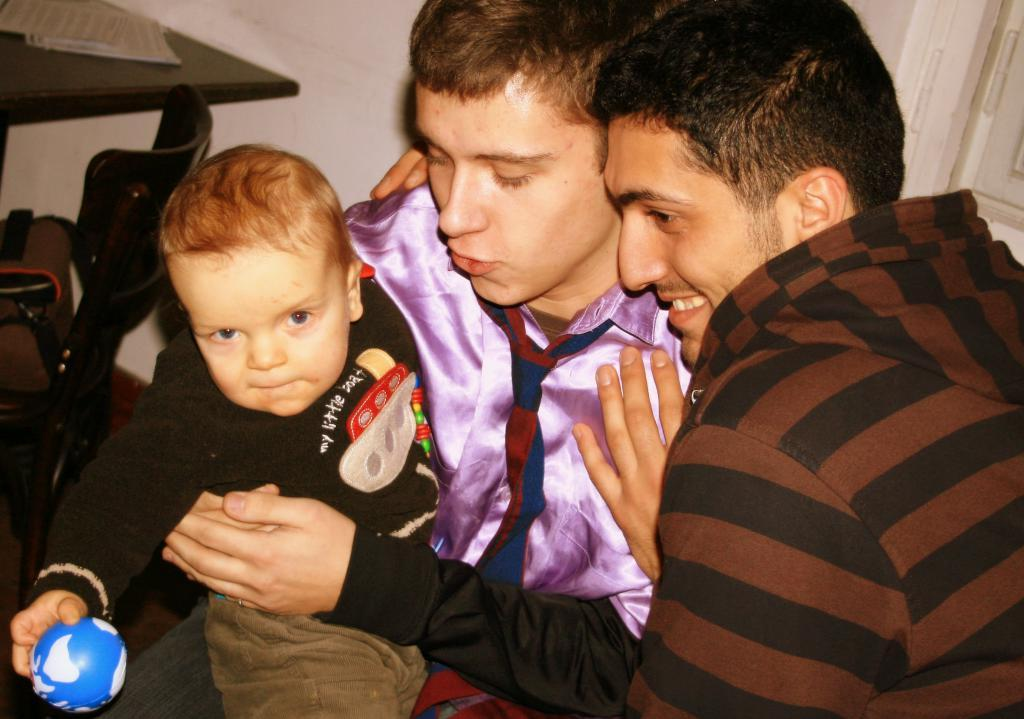How many people are in the image? There are three people in the image: two men and a boy. Where are the men located in the image? The men are on the right side of the image. What is the boy doing in the image? The boy is holding a ball. Where is the boy located in the image? The boy is on the left side of the image. What type of shock can be seen in the image? There is no shock present in the image. What riddle is the boy trying to solve in the image? There is no riddle present in the image; the boy is simply holding a ball. 